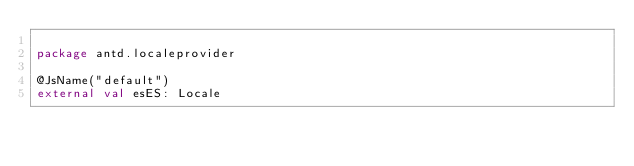Convert code to text. <code><loc_0><loc_0><loc_500><loc_500><_Kotlin_>
package antd.localeprovider

@JsName("default")
external val esES: Locale
</code> 